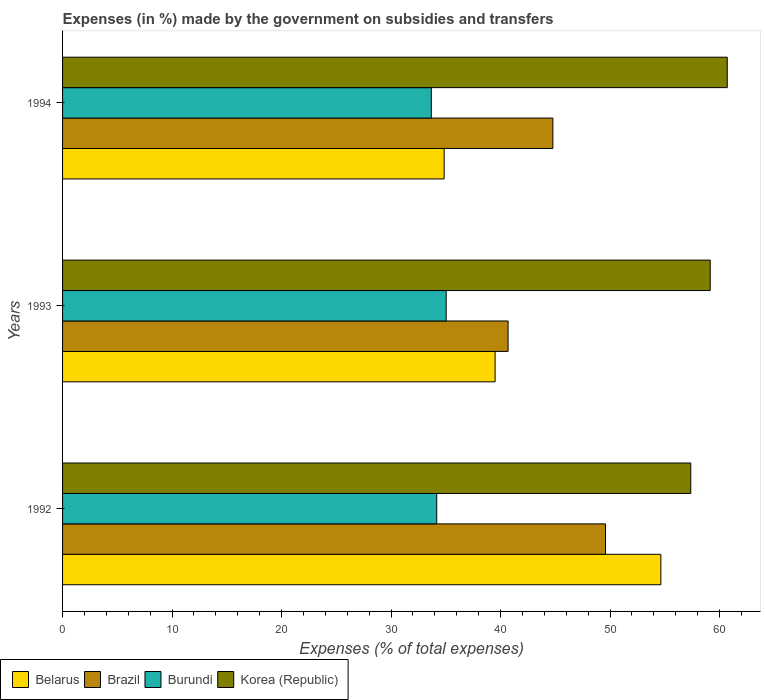How many groups of bars are there?
Provide a succinct answer. 3. Are the number of bars on each tick of the Y-axis equal?
Provide a short and direct response. Yes. How many bars are there on the 3rd tick from the top?
Provide a succinct answer. 4. What is the percentage of expenses made by the government on subsidies and transfers in Brazil in 1994?
Your response must be concise. 44.78. Across all years, what is the maximum percentage of expenses made by the government on subsidies and transfers in Belarus?
Provide a short and direct response. 54.64. Across all years, what is the minimum percentage of expenses made by the government on subsidies and transfers in Brazil?
Offer a terse response. 40.69. In which year was the percentage of expenses made by the government on subsidies and transfers in Belarus minimum?
Offer a very short reply. 1994. What is the total percentage of expenses made by the government on subsidies and transfers in Brazil in the graph?
Give a very brief answer. 135.05. What is the difference between the percentage of expenses made by the government on subsidies and transfers in Brazil in 1992 and that in 1994?
Offer a very short reply. 4.81. What is the difference between the percentage of expenses made by the government on subsidies and transfers in Belarus in 1993 and the percentage of expenses made by the government on subsidies and transfers in Brazil in 1994?
Keep it short and to the point. -5.27. What is the average percentage of expenses made by the government on subsidies and transfers in Korea (Republic) per year?
Provide a short and direct response. 59.07. In the year 1993, what is the difference between the percentage of expenses made by the government on subsidies and transfers in Brazil and percentage of expenses made by the government on subsidies and transfers in Burundi?
Your answer should be very brief. 5.65. In how many years, is the percentage of expenses made by the government on subsidies and transfers in Belarus greater than 56 %?
Keep it short and to the point. 0. What is the ratio of the percentage of expenses made by the government on subsidies and transfers in Belarus in 1992 to that in 1994?
Provide a short and direct response. 1.57. What is the difference between the highest and the second highest percentage of expenses made by the government on subsidies and transfers in Burundi?
Ensure brevity in your answer.  0.86. What is the difference between the highest and the lowest percentage of expenses made by the government on subsidies and transfers in Korea (Republic)?
Offer a terse response. 3.33. Is the sum of the percentage of expenses made by the government on subsidies and transfers in Brazil in 1992 and 1994 greater than the maximum percentage of expenses made by the government on subsidies and transfers in Korea (Republic) across all years?
Your response must be concise. Yes. Is it the case that in every year, the sum of the percentage of expenses made by the government on subsidies and transfers in Burundi and percentage of expenses made by the government on subsidies and transfers in Korea (Republic) is greater than the sum of percentage of expenses made by the government on subsidies and transfers in Brazil and percentage of expenses made by the government on subsidies and transfers in Belarus?
Keep it short and to the point. Yes. What does the 2nd bar from the top in 1994 represents?
Your answer should be very brief. Burundi. What does the 2nd bar from the bottom in 1993 represents?
Keep it short and to the point. Brazil. Is it the case that in every year, the sum of the percentage of expenses made by the government on subsidies and transfers in Belarus and percentage of expenses made by the government on subsidies and transfers in Korea (Republic) is greater than the percentage of expenses made by the government on subsidies and transfers in Burundi?
Your answer should be compact. Yes. What is the difference between two consecutive major ticks on the X-axis?
Your response must be concise. 10. Are the values on the major ticks of X-axis written in scientific E-notation?
Keep it short and to the point. No. Does the graph contain grids?
Keep it short and to the point. No. How are the legend labels stacked?
Provide a succinct answer. Horizontal. What is the title of the graph?
Make the answer very short. Expenses (in %) made by the government on subsidies and transfers. Does "Heavily indebted poor countries" appear as one of the legend labels in the graph?
Keep it short and to the point. No. What is the label or title of the X-axis?
Your answer should be compact. Expenses (% of total expenses). What is the Expenses (% of total expenses) of Belarus in 1992?
Provide a short and direct response. 54.64. What is the Expenses (% of total expenses) of Brazil in 1992?
Offer a terse response. 49.59. What is the Expenses (% of total expenses) in Burundi in 1992?
Provide a short and direct response. 34.17. What is the Expenses (% of total expenses) of Korea (Republic) in 1992?
Offer a terse response. 57.37. What is the Expenses (% of total expenses) in Belarus in 1993?
Keep it short and to the point. 39.5. What is the Expenses (% of total expenses) of Brazil in 1993?
Your answer should be very brief. 40.69. What is the Expenses (% of total expenses) of Burundi in 1993?
Give a very brief answer. 35.03. What is the Expenses (% of total expenses) of Korea (Republic) in 1993?
Offer a very short reply. 59.15. What is the Expenses (% of total expenses) of Belarus in 1994?
Your answer should be very brief. 34.85. What is the Expenses (% of total expenses) in Brazil in 1994?
Make the answer very short. 44.78. What is the Expenses (% of total expenses) of Burundi in 1994?
Provide a succinct answer. 33.68. What is the Expenses (% of total expenses) in Korea (Republic) in 1994?
Your response must be concise. 60.7. Across all years, what is the maximum Expenses (% of total expenses) in Belarus?
Give a very brief answer. 54.64. Across all years, what is the maximum Expenses (% of total expenses) of Brazil?
Provide a short and direct response. 49.59. Across all years, what is the maximum Expenses (% of total expenses) of Burundi?
Your answer should be compact. 35.03. Across all years, what is the maximum Expenses (% of total expenses) of Korea (Republic)?
Ensure brevity in your answer.  60.7. Across all years, what is the minimum Expenses (% of total expenses) in Belarus?
Offer a terse response. 34.85. Across all years, what is the minimum Expenses (% of total expenses) of Brazil?
Offer a terse response. 40.69. Across all years, what is the minimum Expenses (% of total expenses) of Burundi?
Your answer should be compact. 33.68. Across all years, what is the minimum Expenses (% of total expenses) in Korea (Republic)?
Your answer should be very brief. 57.37. What is the total Expenses (% of total expenses) of Belarus in the graph?
Give a very brief answer. 128.99. What is the total Expenses (% of total expenses) of Brazil in the graph?
Ensure brevity in your answer.  135.05. What is the total Expenses (% of total expenses) in Burundi in the graph?
Give a very brief answer. 102.88. What is the total Expenses (% of total expenses) in Korea (Republic) in the graph?
Your response must be concise. 177.22. What is the difference between the Expenses (% of total expenses) of Belarus in 1992 and that in 1993?
Give a very brief answer. 15.14. What is the difference between the Expenses (% of total expenses) of Brazil in 1992 and that in 1993?
Ensure brevity in your answer.  8.9. What is the difference between the Expenses (% of total expenses) in Burundi in 1992 and that in 1993?
Your answer should be very brief. -0.86. What is the difference between the Expenses (% of total expenses) of Korea (Republic) in 1992 and that in 1993?
Give a very brief answer. -1.78. What is the difference between the Expenses (% of total expenses) of Belarus in 1992 and that in 1994?
Ensure brevity in your answer.  19.79. What is the difference between the Expenses (% of total expenses) of Brazil in 1992 and that in 1994?
Offer a very short reply. 4.81. What is the difference between the Expenses (% of total expenses) in Burundi in 1992 and that in 1994?
Ensure brevity in your answer.  0.49. What is the difference between the Expenses (% of total expenses) of Korea (Republic) in 1992 and that in 1994?
Offer a very short reply. -3.33. What is the difference between the Expenses (% of total expenses) in Belarus in 1993 and that in 1994?
Your answer should be compact. 4.65. What is the difference between the Expenses (% of total expenses) of Brazil in 1993 and that in 1994?
Provide a short and direct response. -4.09. What is the difference between the Expenses (% of total expenses) in Burundi in 1993 and that in 1994?
Offer a very short reply. 1.36. What is the difference between the Expenses (% of total expenses) in Korea (Republic) in 1993 and that in 1994?
Offer a terse response. -1.56. What is the difference between the Expenses (% of total expenses) in Belarus in 1992 and the Expenses (% of total expenses) in Brazil in 1993?
Offer a very short reply. 13.95. What is the difference between the Expenses (% of total expenses) in Belarus in 1992 and the Expenses (% of total expenses) in Burundi in 1993?
Your answer should be very brief. 19.6. What is the difference between the Expenses (% of total expenses) in Belarus in 1992 and the Expenses (% of total expenses) in Korea (Republic) in 1993?
Your answer should be very brief. -4.51. What is the difference between the Expenses (% of total expenses) of Brazil in 1992 and the Expenses (% of total expenses) of Burundi in 1993?
Give a very brief answer. 14.55. What is the difference between the Expenses (% of total expenses) of Brazil in 1992 and the Expenses (% of total expenses) of Korea (Republic) in 1993?
Ensure brevity in your answer.  -9.56. What is the difference between the Expenses (% of total expenses) in Burundi in 1992 and the Expenses (% of total expenses) in Korea (Republic) in 1993?
Ensure brevity in your answer.  -24.98. What is the difference between the Expenses (% of total expenses) in Belarus in 1992 and the Expenses (% of total expenses) in Brazil in 1994?
Provide a succinct answer. 9.86. What is the difference between the Expenses (% of total expenses) of Belarus in 1992 and the Expenses (% of total expenses) of Burundi in 1994?
Offer a very short reply. 20.96. What is the difference between the Expenses (% of total expenses) of Belarus in 1992 and the Expenses (% of total expenses) of Korea (Republic) in 1994?
Offer a terse response. -6.06. What is the difference between the Expenses (% of total expenses) in Brazil in 1992 and the Expenses (% of total expenses) in Burundi in 1994?
Provide a succinct answer. 15.91. What is the difference between the Expenses (% of total expenses) in Brazil in 1992 and the Expenses (% of total expenses) in Korea (Republic) in 1994?
Keep it short and to the point. -11.12. What is the difference between the Expenses (% of total expenses) of Burundi in 1992 and the Expenses (% of total expenses) of Korea (Republic) in 1994?
Provide a succinct answer. -26.53. What is the difference between the Expenses (% of total expenses) in Belarus in 1993 and the Expenses (% of total expenses) in Brazil in 1994?
Your answer should be compact. -5.27. What is the difference between the Expenses (% of total expenses) in Belarus in 1993 and the Expenses (% of total expenses) in Burundi in 1994?
Give a very brief answer. 5.83. What is the difference between the Expenses (% of total expenses) in Belarus in 1993 and the Expenses (% of total expenses) in Korea (Republic) in 1994?
Make the answer very short. -21.2. What is the difference between the Expenses (% of total expenses) in Brazil in 1993 and the Expenses (% of total expenses) in Burundi in 1994?
Ensure brevity in your answer.  7.01. What is the difference between the Expenses (% of total expenses) of Brazil in 1993 and the Expenses (% of total expenses) of Korea (Republic) in 1994?
Ensure brevity in your answer.  -20.02. What is the difference between the Expenses (% of total expenses) of Burundi in 1993 and the Expenses (% of total expenses) of Korea (Republic) in 1994?
Give a very brief answer. -25.67. What is the average Expenses (% of total expenses) in Belarus per year?
Offer a very short reply. 43. What is the average Expenses (% of total expenses) in Brazil per year?
Your response must be concise. 45.02. What is the average Expenses (% of total expenses) of Burundi per year?
Give a very brief answer. 34.29. What is the average Expenses (% of total expenses) of Korea (Republic) per year?
Your answer should be compact. 59.07. In the year 1992, what is the difference between the Expenses (% of total expenses) in Belarus and Expenses (% of total expenses) in Brazil?
Offer a terse response. 5.05. In the year 1992, what is the difference between the Expenses (% of total expenses) in Belarus and Expenses (% of total expenses) in Burundi?
Offer a terse response. 20.47. In the year 1992, what is the difference between the Expenses (% of total expenses) in Belarus and Expenses (% of total expenses) in Korea (Republic)?
Your answer should be very brief. -2.73. In the year 1992, what is the difference between the Expenses (% of total expenses) in Brazil and Expenses (% of total expenses) in Burundi?
Offer a very short reply. 15.41. In the year 1992, what is the difference between the Expenses (% of total expenses) in Brazil and Expenses (% of total expenses) in Korea (Republic)?
Offer a terse response. -7.78. In the year 1992, what is the difference between the Expenses (% of total expenses) of Burundi and Expenses (% of total expenses) of Korea (Republic)?
Make the answer very short. -23.2. In the year 1993, what is the difference between the Expenses (% of total expenses) in Belarus and Expenses (% of total expenses) in Brazil?
Offer a very short reply. -1.18. In the year 1993, what is the difference between the Expenses (% of total expenses) in Belarus and Expenses (% of total expenses) in Burundi?
Ensure brevity in your answer.  4.47. In the year 1993, what is the difference between the Expenses (% of total expenses) of Belarus and Expenses (% of total expenses) of Korea (Republic)?
Provide a succinct answer. -19.64. In the year 1993, what is the difference between the Expenses (% of total expenses) of Brazil and Expenses (% of total expenses) of Burundi?
Your answer should be very brief. 5.65. In the year 1993, what is the difference between the Expenses (% of total expenses) in Brazil and Expenses (% of total expenses) in Korea (Republic)?
Your response must be concise. -18.46. In the year 1993, what is the difference between the Expenses (% of total expenses) of Burundi and Expenses (% of total expenses) of Korea (Republic)?
Your answer should be very brief. -24.11. In the year 1994, what is the difference between the Expenses (% of total expenses) of Belarus and Expenses (% of total expenses) of Brazil?
Offer a terse response. -9.93. In the year 1994, what is the difference between the Expenses (% of total expenses) of Belarus and Expenses (% of total expenses) of Burundi?
Offer a very short reply. 1.17. In the year 1994, what is the difference between the Expenses (% of total expenses) in Belarus and Expenses (% of total expenses) in Korea (Republic)?
Keep it short and to the point. -25.86. In the year 1994, what is the difference between the Expenses (% of total expenses) in Brazil and Expenses (% of total expenses) in Korea (Republic)?
Provide a succinct answer. -15.93. In the year 1994, what is the difference between the Expenses (% of total expenses) in Burundi and Expenses (% of total expenses) in Korea (Republic)?
Provide a succinct answer. -27.03. What is the ratio of the Expenses (% of total expenses) in Belarus in 1992 to that in 1993?
Make the answer very short. 1.38. What is the ratio of the Expenses (% of total expenses) in Brazil in 1992 to that in 1993?
Provide a succinct answer. 1.22. What is the ratio of the Expenses (% of total expenses) in Burundi in 1992 to that in 1993?
Make the answer very short. 0.98. What is the ratio of the Expenses (% of total expenses) in Korea (Republic) in 1992 to that in 1993?
Keep it short and to the point. 0.97. What is the ratio of the Expenses (% of total expenses) in Belarus in 1992 to that in 1994?
Provide a short and direct response. 1.57. What is the ratio of the Expenses (% of total expenses) of Brazil in 1992 to that in 1994?
Keep it short and to the point. 1.11. What is the ratio of the Expenses (% of total expenses) of Burundi in 1992 to that in 1994?
Give a very brief answer. 1.01. What is the ratio of the Expenses (% of total expenses) in Korea (Republic) in 1992 to that in 1994?
Offer a terse response. 0.95. What is the ratio of the Expenses (% of total expenses) of Belarus in 1993 to that in 1994?
Your response must be concise. 1.13. What is the ratio of the Expenses (% of total expenses) of Brazil in 1993 to that in 1994?
Ensure brevity in your answer.  0.91. What is the ratio of the Expenses (% of total expenses) of Burundi in 1993 to that in 1994?
Make the answer very short. 1.04. What is the ratio of the Expenses (% of total expenses) in Korea (Republic) in 1993 to that in 1994?
Your answer should be compact. 0.97. What is the difference between the highest and the second highest Expenses (% of total expenses) of Belarus?
Keep it short and to the point. 15.14. What is the difference between the highest and the second highest Expenses (% of total expenses) of Brazil?
Provide a short and direct response. 4.81. What is the difference between the highest and the second highest Expenses (% of total expenses) in Burundi?
Your response must be concise. 0.86. What is the difference between the highest and the second highest Expenses (% of total expenses) in Korea (Republic)?
Provide a succinct answer. 1.56. What is the difference between the highest and the lowest Expenses (% of total expenses) in Belarus?
Give a very brief answer. 19.79. What is the difference between the highest and the lowest Expenses (% of total expenses) of Brazil?
Make the answer very short. 8.9. What is the difference between the highest and the lowest Expenses (% of total expenses) of Burundi?
Give a very brief answer. 1.36. What is the difference between the highest and the lowest Expenses (% of total expenses) of Korea (Republic)?
Your response must be concise. 3.33. 